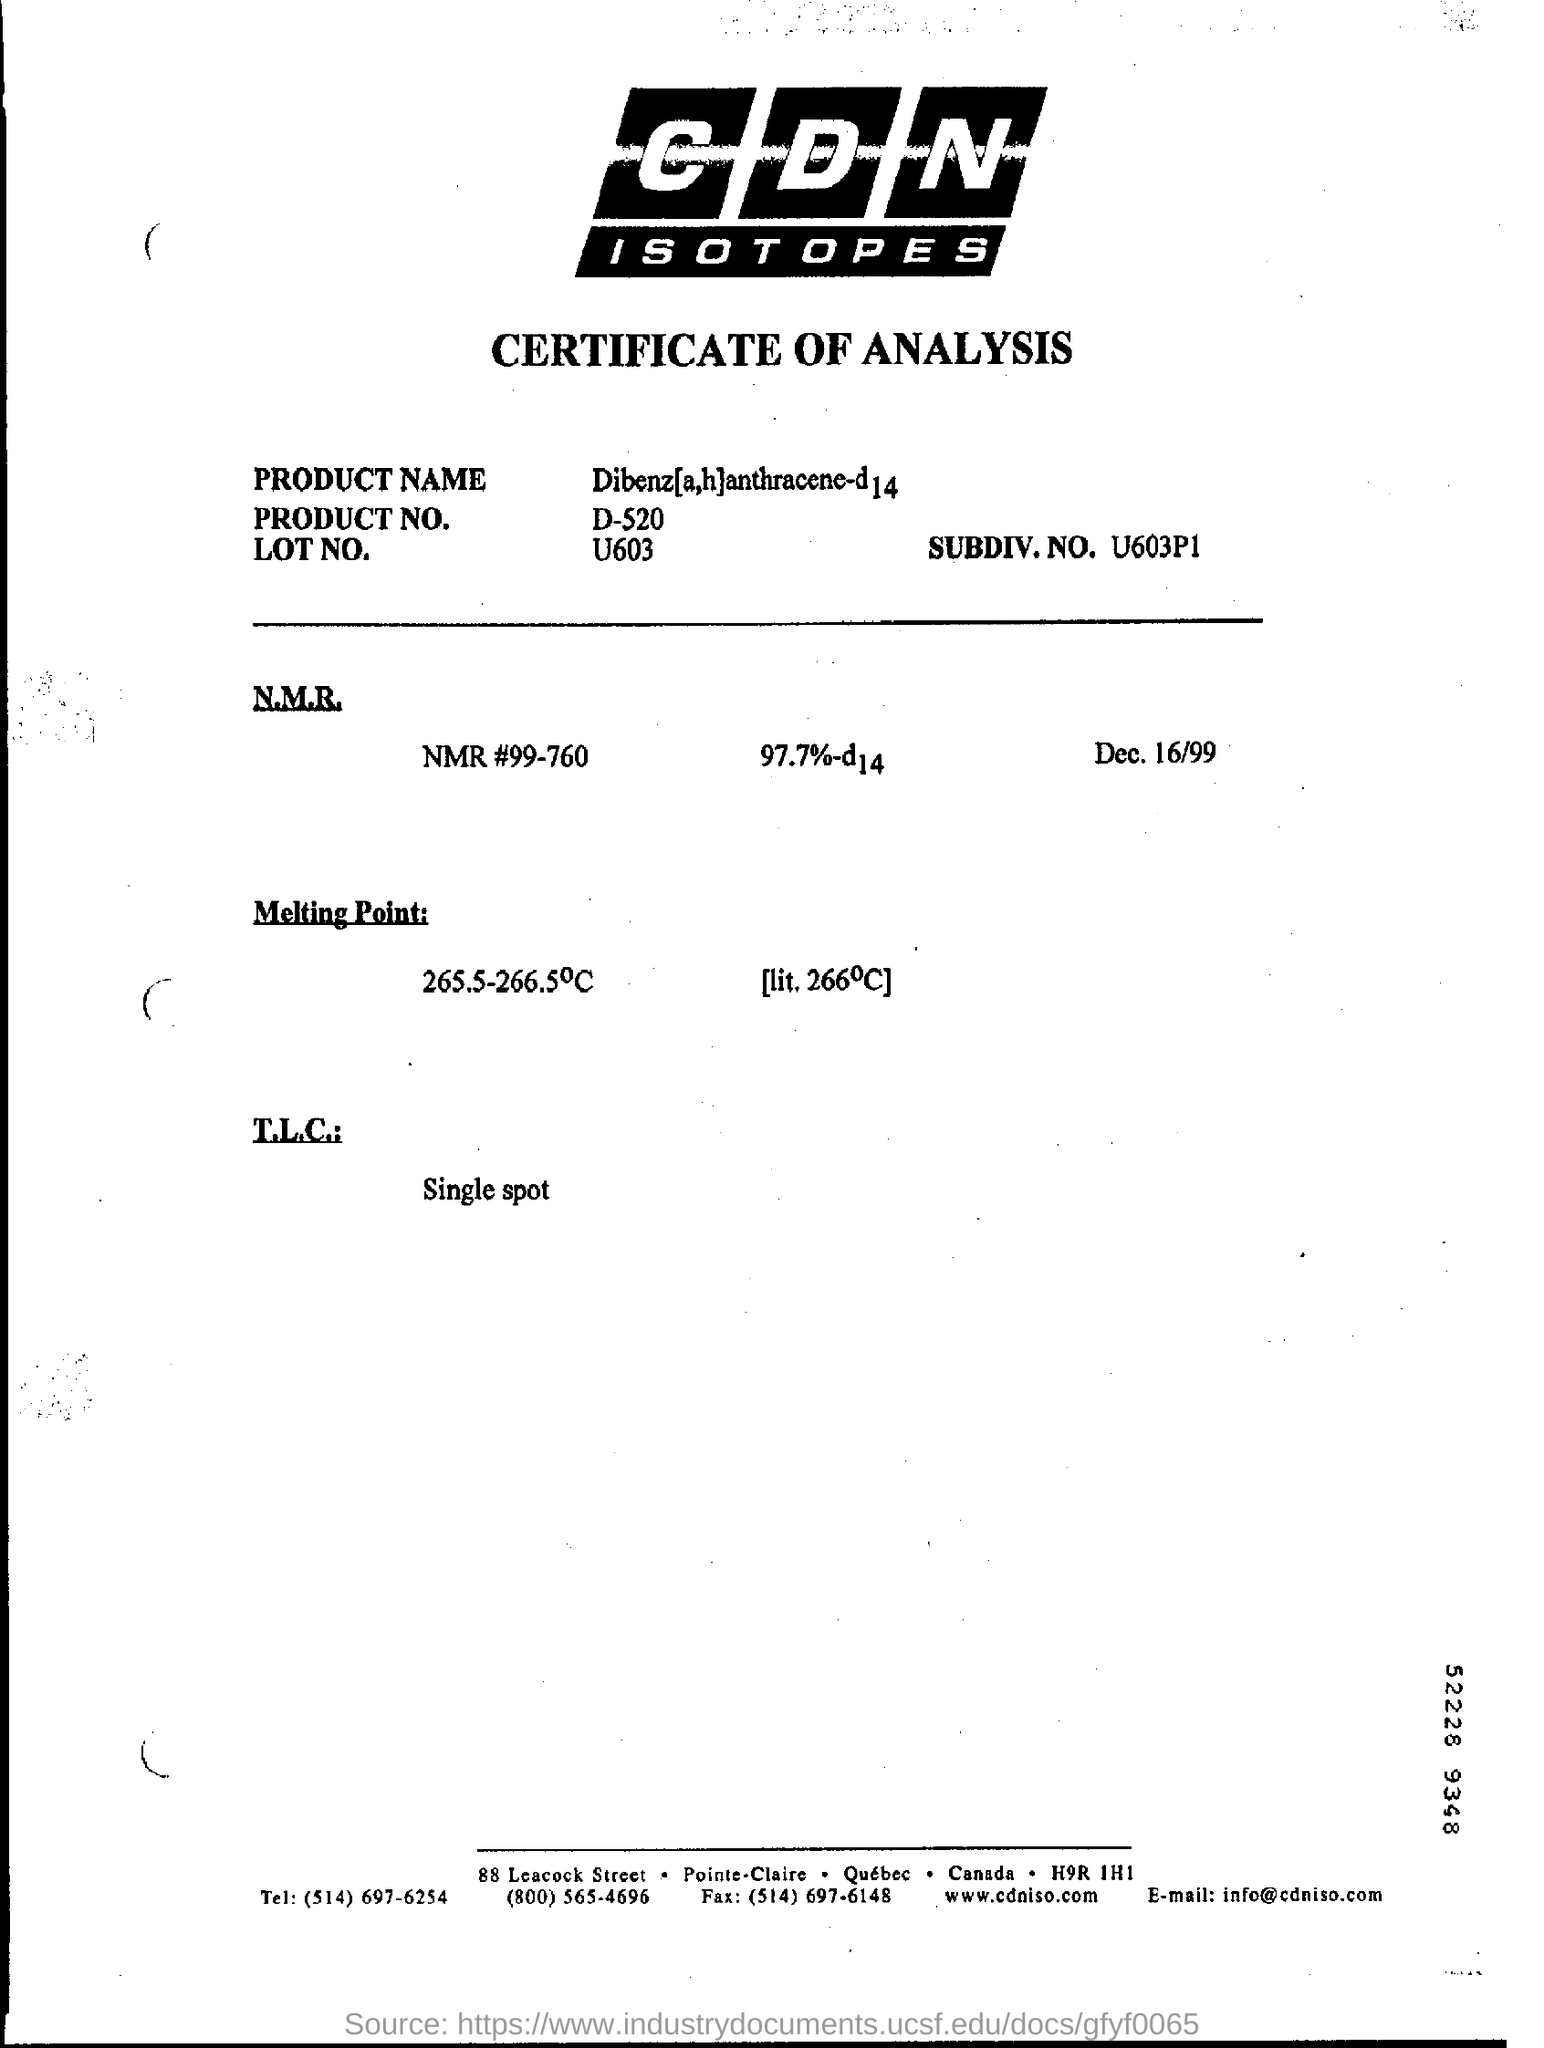Draw attention to some important aspects in this diagram. Please identify the subdivision number U603p1.. T.L.C stands for Total Lending Control, a single spot platform that provides innovative and comprehensive solutions for lenders and borrowers to achieve their financial goals. The date mentioned on this page is December 16, 1999. NMR# is a unique identifier that consists of 99-760. 